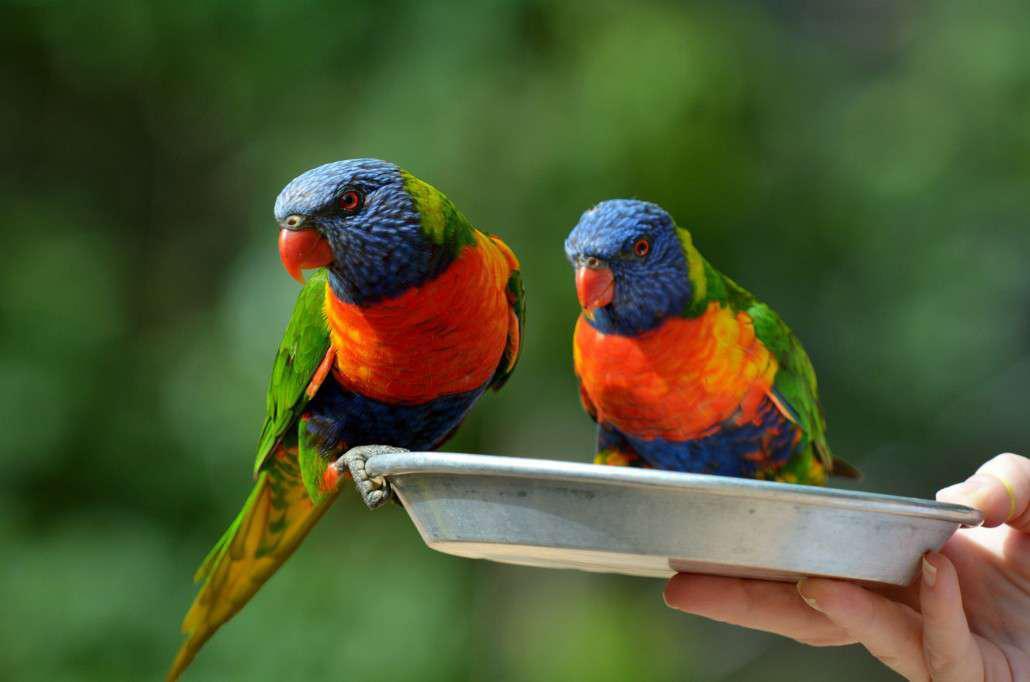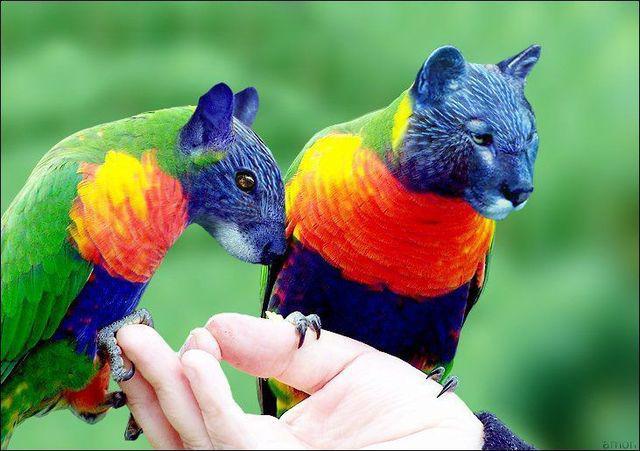The first image is the image on the left, the second image is the image on the right. Analyze the images presented: Is the assertion "A human hand is offering food to birds in the left image." valid? Answer yes or no. Yes. 